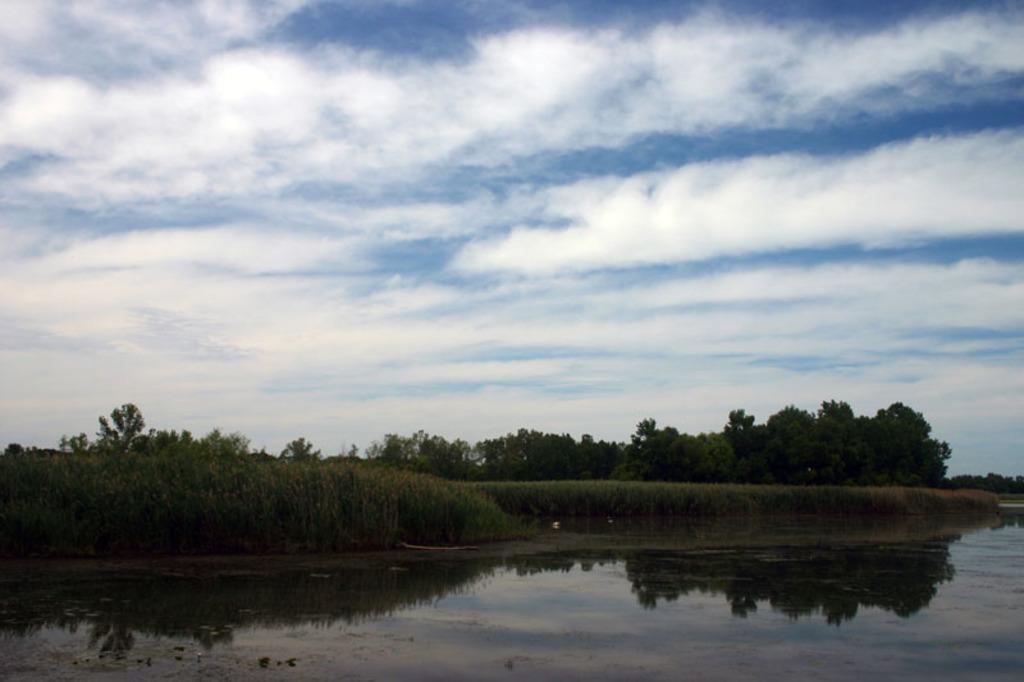Can you describe this image briefly? In this image at front there is water and grass. At the background there are trees. At the backside of the image there is sky. 